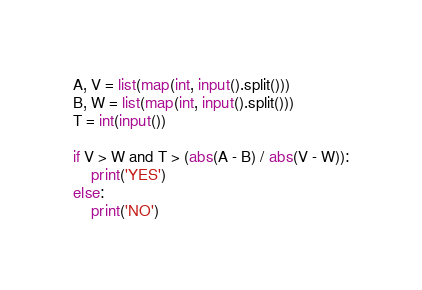Convert code to text. <code><loc_0><loc_0><loc_500><loc_500><_Python_>A, V = list(map(int, input().split()))
B, W = list(map(int, input().split()))
T = int(input())

if V > W and T > (abs(A - B) / abs(V - W)):
    print('YES')
else:
    print('NO')</code> 